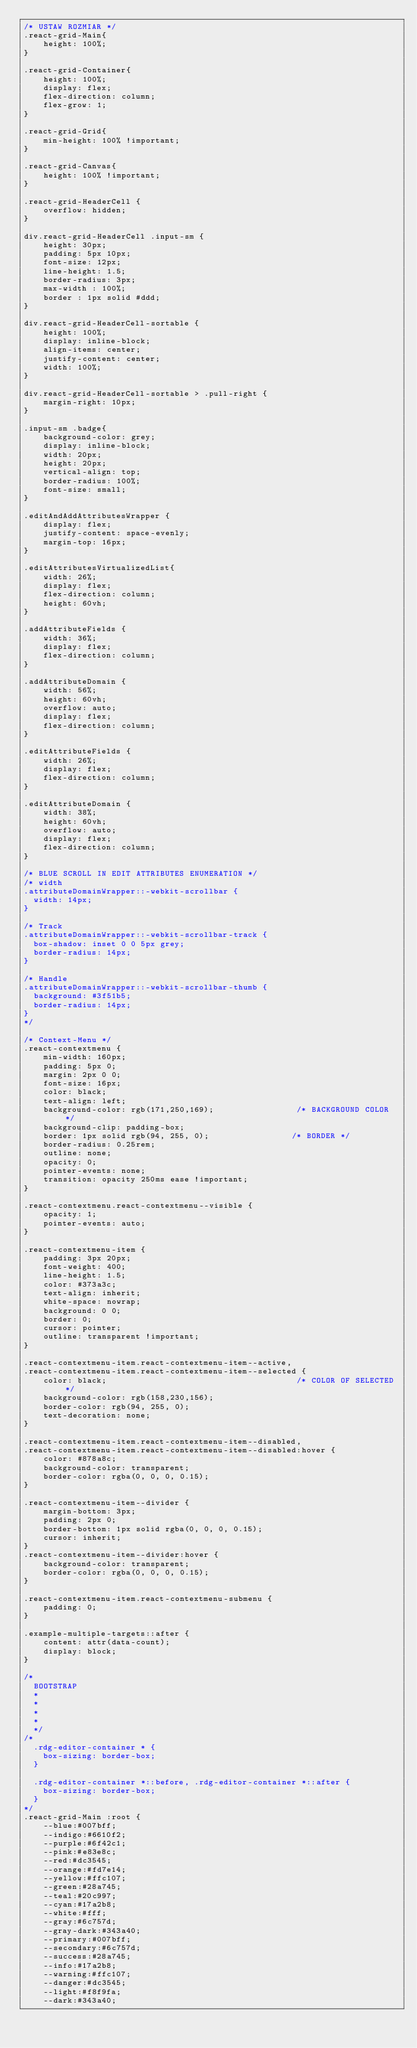Convert code to text. <code><loc_0><loc_0><loc_500><loc_500><_CSS_>/* USTAW ROZMIAR */
.react-grid-Main{
    height: 100%;
}

.react-grid-Container{
    height: 100%;
    display: flex;
    flex-direction: column;
    flex-grow: 1;
}

.react-grid-Grid{
    min-height: 100% !important;
}

.react-grid-Canvas{
    height: 100% !important;
}

.react-grid-HeaderCell {
    overflow: hidden;
}

div.react-grid-HeaderCell .input-sm {
    height: 30px;
    padding: 5px 10px;
    font-size: 12px;
    line-height: 1.5;
    border-radius: 3px;
    max-width : 100%;
    border : 1px solid #ddd;
}

div.react-grid-HeaderCell-sortable {
    height: 100%;
    display: inline-block;
    align-items: center;
    justify-content: center;
    width: 100%;
}

div.react-grid-HeaderCell-sortable > .pull-right {
    margin-right: 10px;
}

.input-sm .badge{
    background-color: grey;
    display: inline-block;
    width: 20px;
    height: 20px;
    vertical-align: top;
    border-radius: 100%;
    font-size: small;
}

.editAndAddAttributesWrapper {
    display: flex;
    justify-content: space-evenly;
    margin-top: 16px;
}

.editAttributesVirtualizedList{
    width: 26%;
    display: flex;
    flex-direction: column;
    height: 60vh;
}

.addAttributeFields {
    width: 36%;
    display: flex;
    flex-direction: column;
}

.addAttributeDomain {
    width: 56%;
    height: 60vh;
    overflow: auto;
    display: flex;
    flex-direction: column;
}

.editAttributeFields {
    width: 26%;
    display: flex;
    flex-direction: column;
}

.editAttributeDomain {
    width: 38%;
    height: 60vh;
    overflow: auto;
    display: flex;
    flex-direction: column;
}

/* BLUE SCROLL IN EDIT ATTRIBUTES ENUMERATION */
/* width
.attributeDomainWrapper::-webkit-scrollbar {
  width: 14px;
}

/* Track
.attributeDomainWrapper::-webkit-scrollbar-track {
  box-shadow: inset 0 0 5px grey;
  border-radius: 14px;
}

/* Handle
.attributeDomainWrapper::-webkit-scrollbar-thumb {
  background: #3f51b5;
  border-radius: 14px;
}
*/

/* Context-Menu */
.react-contextmenu {
    min-width: 160px;
    padding: 5px 0;
    margin: 2px 0 0;
    font-size: 16px;
    color: black;
    text-align: left;
    background-color: rgb(171,250,169);                 /* BACKGROUND COLOR */
    background-clip: padding-box;
    border: 1px solid rgb(94, 255, 0);                 /* BORDER */
    border-radius: 0.25rem;
    outline: none;
    opacity: 0;
    pointer-events: none;
    transition: opacity 250ms ease !important;
}

.react-contextmenu.react-contextmenu--visible {
    opacity: 1;
    pointer-events: auto;
}

.react-contextmenu-item {
    padding: 3px 20px;
    font-weight: 400;
    line-height: 1.5;
    color: #373a3c;
    text-align: inherit;
    white-space: nowrap;
    background: 0 0;
    border: 0;
    cursor: pointer;
    outline: transparent !important;
}

.react-contextmenu-item.react-contextmenu-item--active,
.react-contextmenu-item.react-contextmenu-item--selected {
    color: black;                                       /* COLOR OF SELECTED */
    background-color: rgb(158,230,156);
    border-color: rgb(94, 255, 0);
    text-decoration: none;
}

.react-contextmenu-item.react-contextmenu-item--disabled,
.react-contextmenu-item.react-contextmenu-item--disabled:hover {
    color: #878a8c;
    background-color: transparent;
    border-color: rgba(0, 0, 0, 0.15);
}

.react-contextmenu-item--divider {
    margin-bottom: 3px;
    padding: 2px 0;
    border-bottom: 1px solid rgba(0, 0, 0, 0.15);
    cursor: inherit;
}
.react-contextmenu-item--divider:hover {
    background-color: transparent;
    border-color: rgba(0, 0, 0, 0.15);
}

.react-contextmenu-item.react-contextmenu-submenu {
    padding: 0;
}

.example-multiple-targets::after {
    content: attr(data-count);
    display: block;
}

/*
  BOOTSTRAP
  *
  *
  *
  *
  */
/*
  .rdg-editor-container * {
    box-sizing: border-box;
  }

  .rdg-editor-container *::before, .rdg-editor-container *::after {
    box-sizing: border-box;
  }
*/
.react-grid-Main :root {
    --blue:#007bff;
    --indigo:#6610f2;
    --purple:#6f42c1;
    --pink:#e83e8c;
    --red:#dc3545;
    --orange:#fd7e14;
    --yellow:#ffc107;
    --green:#28a745;
    --teal:#20c997;
    --cyan:#17a2b8;
    --white:#fff;
    --gray:#6c757d;
    --gray-dark:#343a40;
    --primary:#007bff;
    --secondary:#6c757d;
    --success:#28a745;
    --info:#17a2b8;
    --warning:#ffc107;
    --danger:#dc3545;
    --light:#f8f9fa;
    --dark:#343a40;</code> 